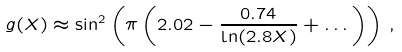<formula> <loc_0><loc_0><loc_500><loc_500>g ( X ) \approx \sin ^ { 2 } \left ( \pi \left ( 2 . 0 2 - \frac { 0 . 7 4 } { \ln ( 2 . 8 X ) } + \dots \right ) \right ) \, ,</formula> 